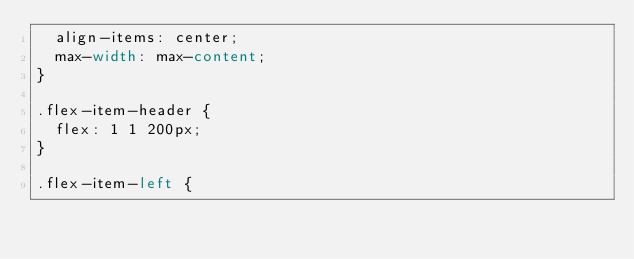<code> <loc_0><loc_0><loc_500><loc_500><_CSS_>  align-items: center;
  max-width: max-content;
}

.flex-item-header {
  flex: 1 1 200px;
}

.flex-item-left {</code> 